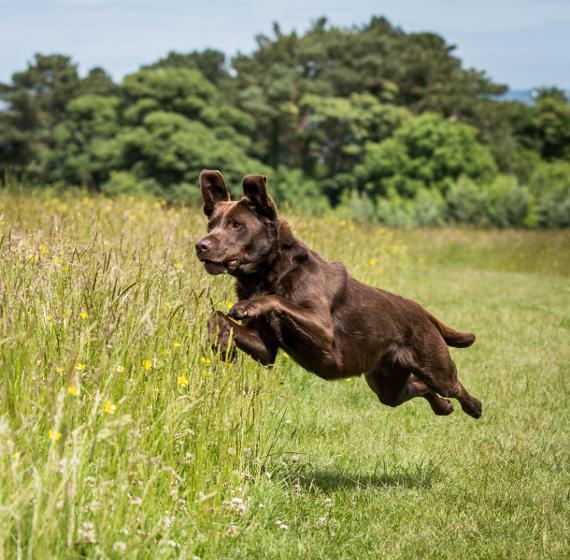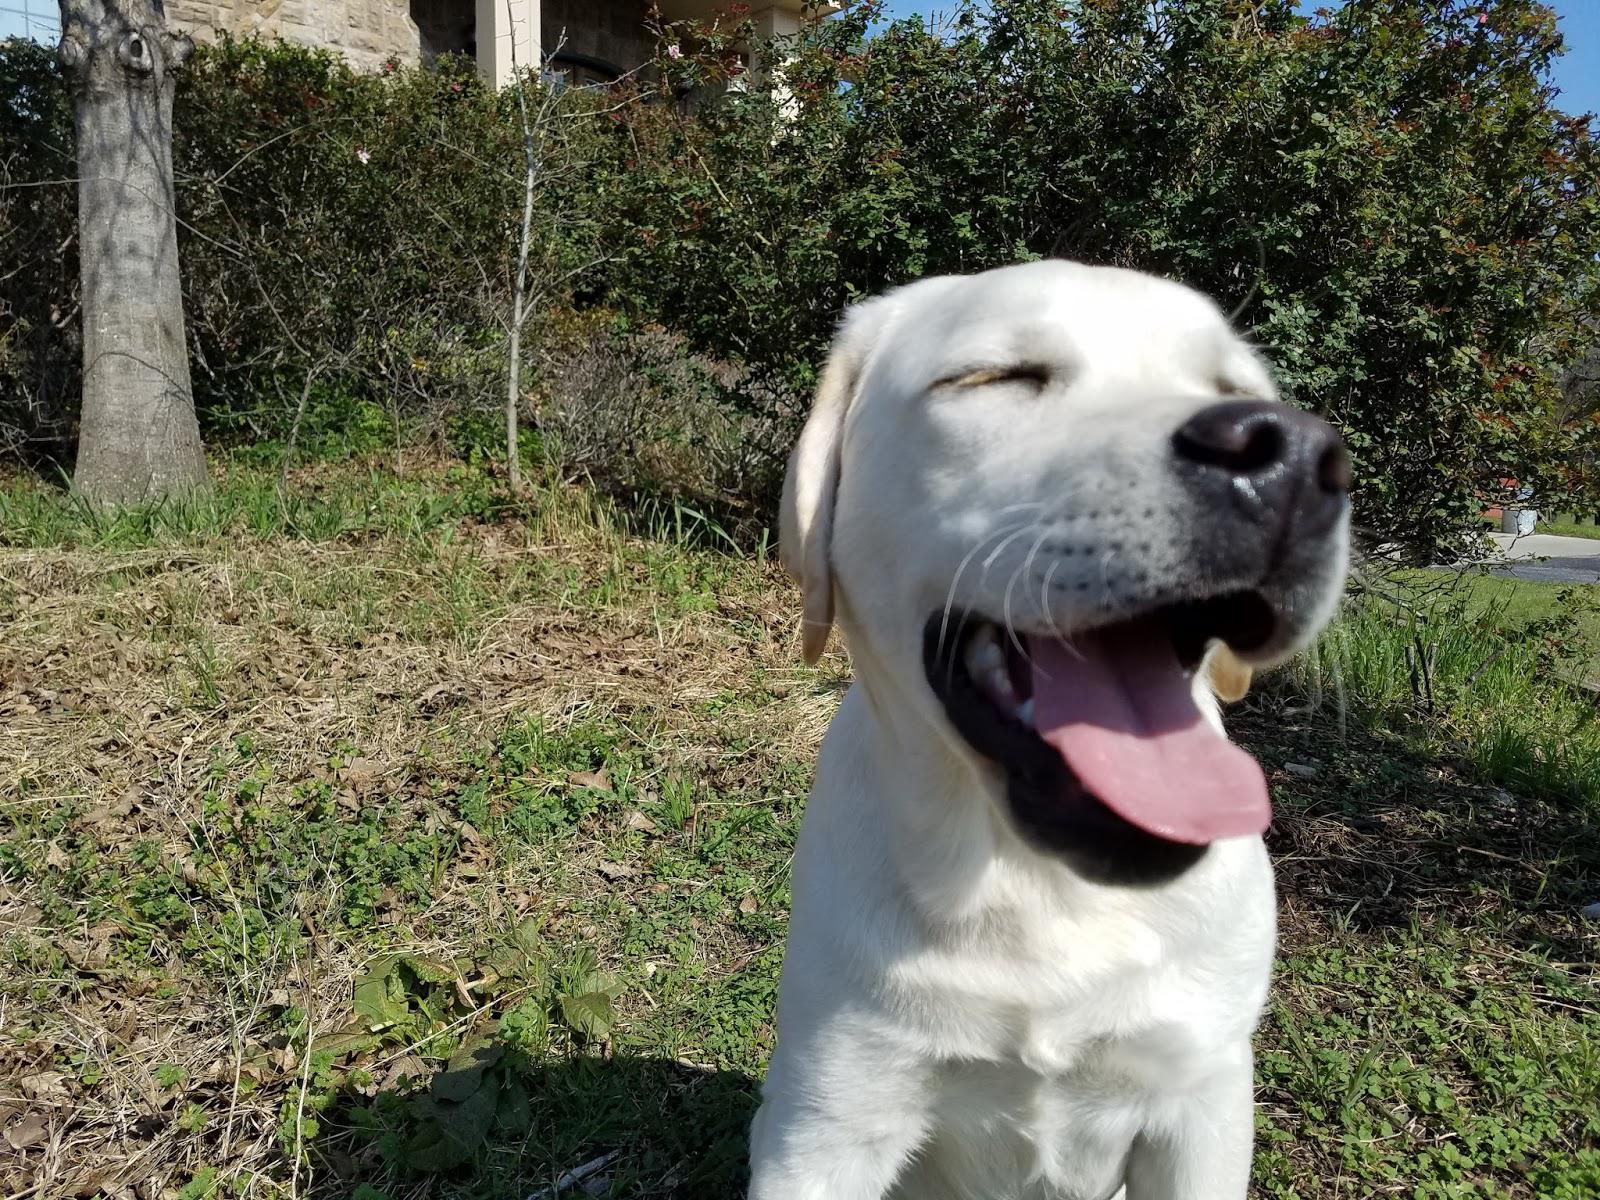The first image is the image on the left, the second image is the image on the right. Assess this claim about the two images: "There are no more than four labradors outside.". Correct or not? Answer yes or no. Yes. The first image is the image on the left, the second image is the image on the right. For the images shown, is this caption "Left image shows one dog, which is solid brown and pictured outdoors." true? Answer yes or no. Yes. 